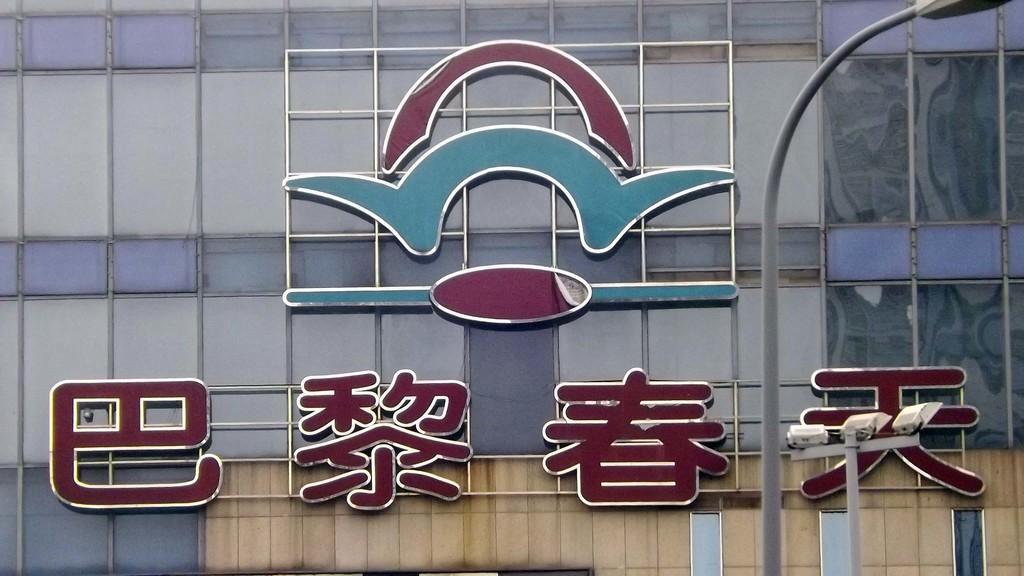In one or two sentences, can you explain what this image depicts? In this picture we can see a logo and some letters written in a foreign language. On the right side, we can see a lamp pole. 